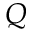Convert formula to latex. <formula><loc_0><loc_0><loc_500><loc_500>Q</formula> 